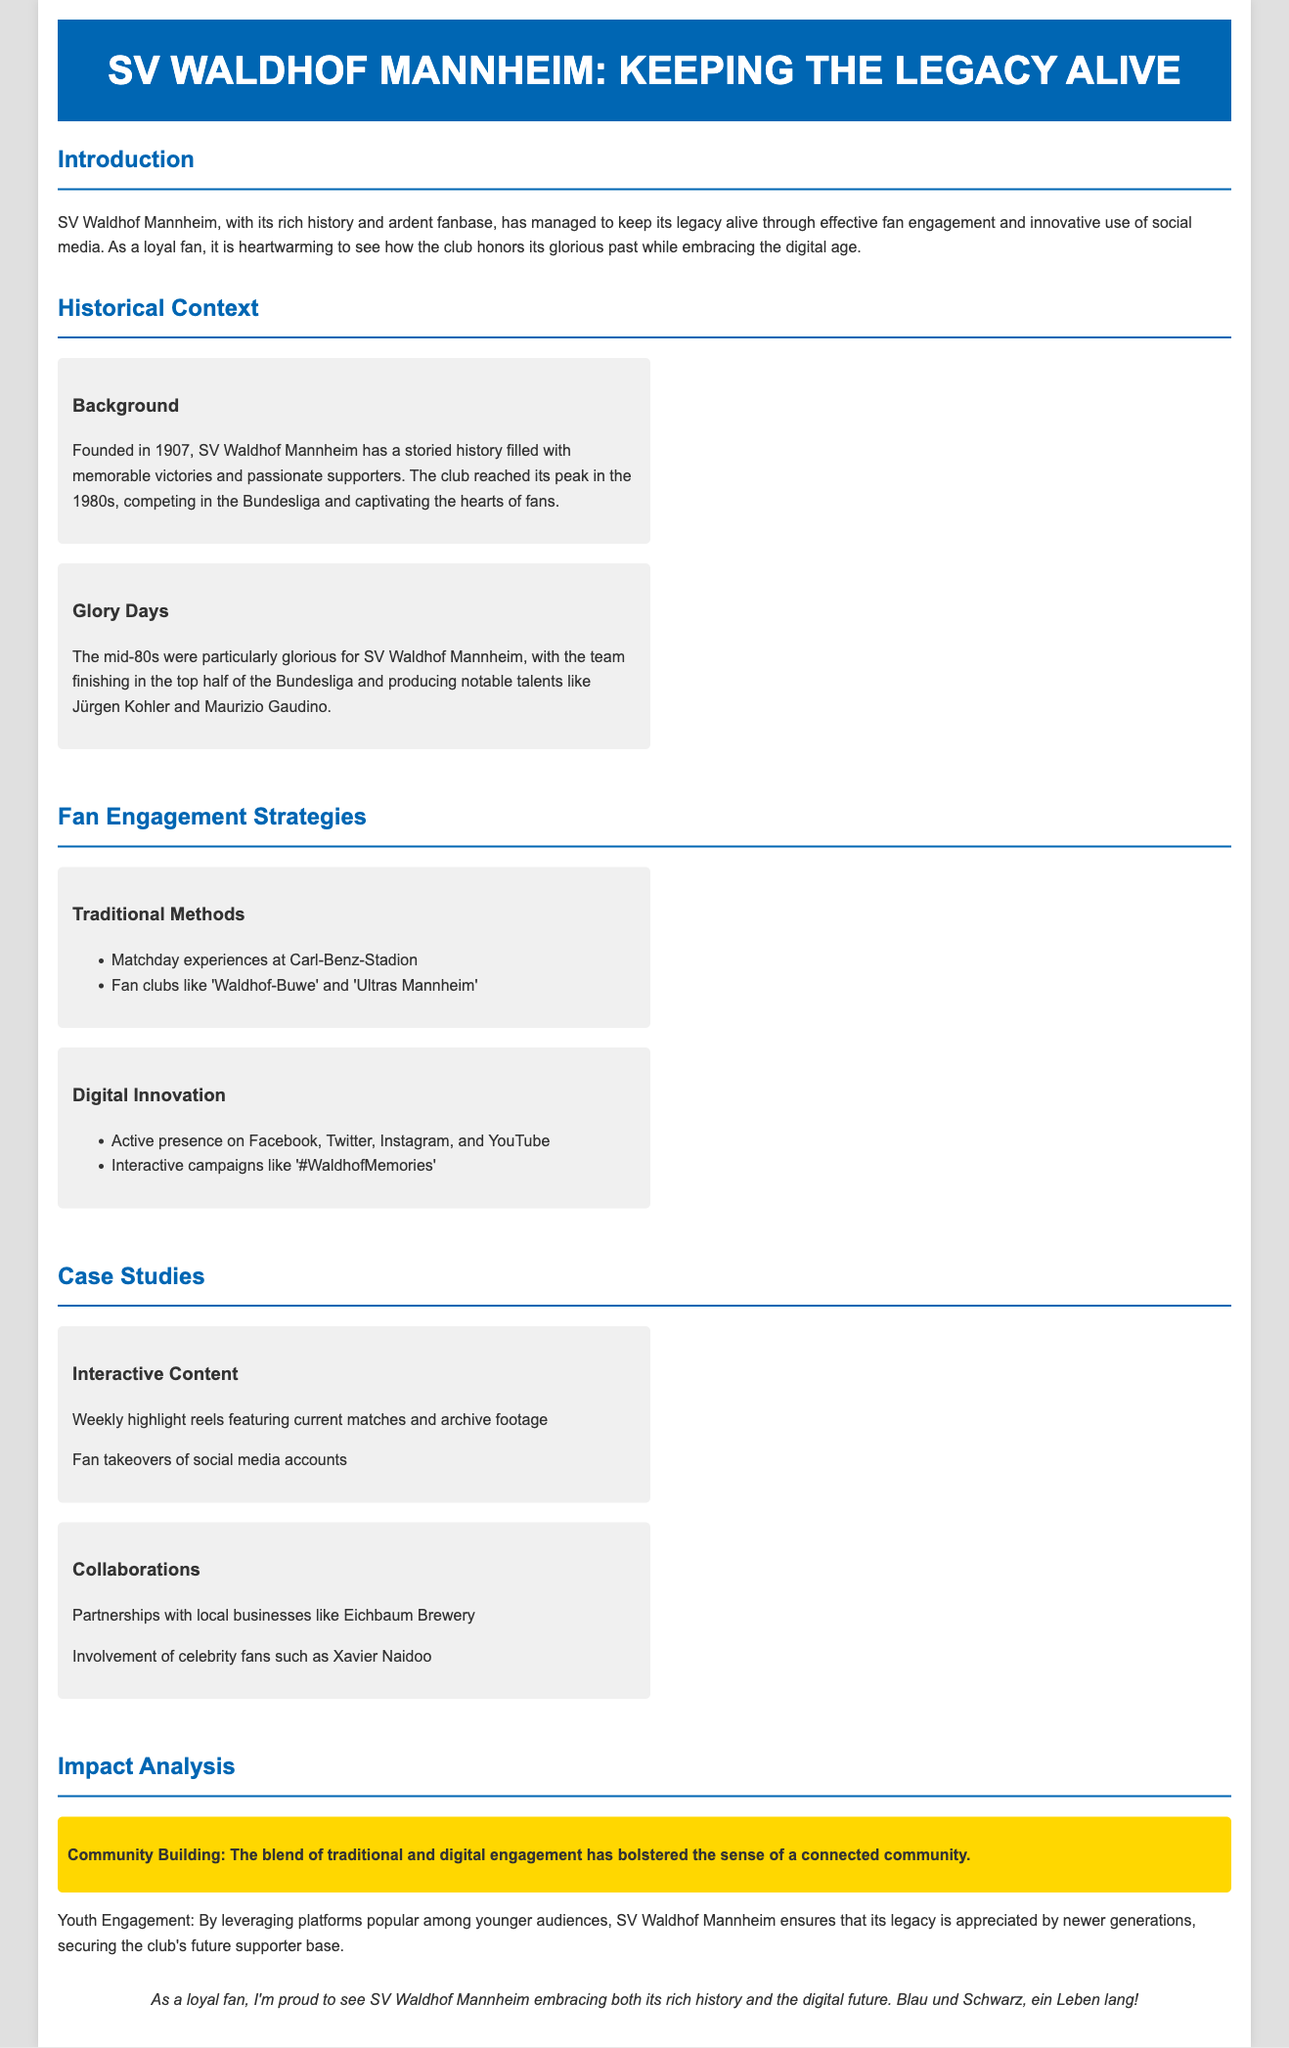What year was SV Waldhof Mannheim founded? The document states that SV Waldhof Mannheim was founded in 1907.
Answer: 1907 What notable players emerged from the club in the 1980s? The document mentions Jürgen Kohler and Maurizio Gaudino as notable talents from the club during the mid-80s.
Answer: Jürgen Kohler and Maurizio Gaudino What social media platforms does SV Waldhof Mannheim actively use? The document lists Facebook, Twitter, Instagram, and YouTube as the platforms the club is active on.
Answer: Facebook, Twitter, Instagram, YouTube What is the name of the fan club mentioned in the document? The document mentions fan clubs like 'Waldhof-Buwe' and 'Ultras Mannheim'.
Answer: Waldhof-Buwe, Ultras Mannheim What type of content is highlighted as part of the interactive content strategy? The document discusses weekly highlight reels featuring current matches and archive footage as interactive content.
Answer: Weekly highlight reels How does SV Waldhof Mannheim engage with the community? The document indicates that the blend of traditional and digital engagement bolsters community connection.
Answer: Community connection Which brewery is mentioned as a partner in the document? The document refers to Eichbaum Brewery as a partner with the club.
Answer: Eichbaum Brewery What is the overall impact of the club's fan engagement strategy? The document highlights community building and youth engagement as the outcomes of the fan engagement strategies.
Answer: Community building, youth engagement 